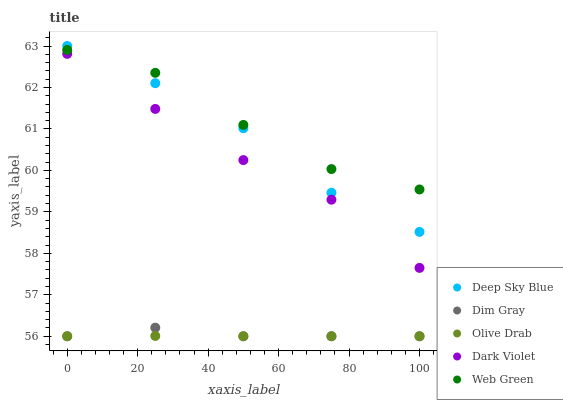Does Olive Drab have the minimum area under the curve?
Answer yes or no. Yes. Does Web Green have the maximum area under the curve?
Answer yes or no. Yes. Does Dark Violet have the minimum area under the curve?
Answer yes or no. No. Does Dark Violet have the maximum area under the curve?
Answer yes or no. No. Is Olive Drab the smoothest?
Answer yes or no. Yes. Is Web Green the roughest?
Answer yes or no. Yes. Is Dark Violet the smoothest?
Answer yes or no. No. Is Dark Violet the roughest?
Answer yes or no. No. Does Dim Gray have the lowest value?
Answer yes or no. Yes. Does Dark Violet have the lowest value?
Answer yes or no. No. Does Deep Sky Blue have the highest value?
Answer yes or no. Yes. Does Dark Violet have the highest value?
Answer yes or no. No. Is Dim Gray less than Deep Sky Blue?
Answer yes or no. Yes. Is Web Green greater than Olive Drab?
Answer yes or no. Yes. Does Olive Drab intersect Dim Gray?
Answer yes or no. Yes. Is Olive Drab less than Dim Gray?
Answer yes or no. No. Is Olive Drab greater than Dim Gray?
Answer yes or no. No. Does Dim Gray intersect Deep Sky Blue?
Answer yes or no. No. 